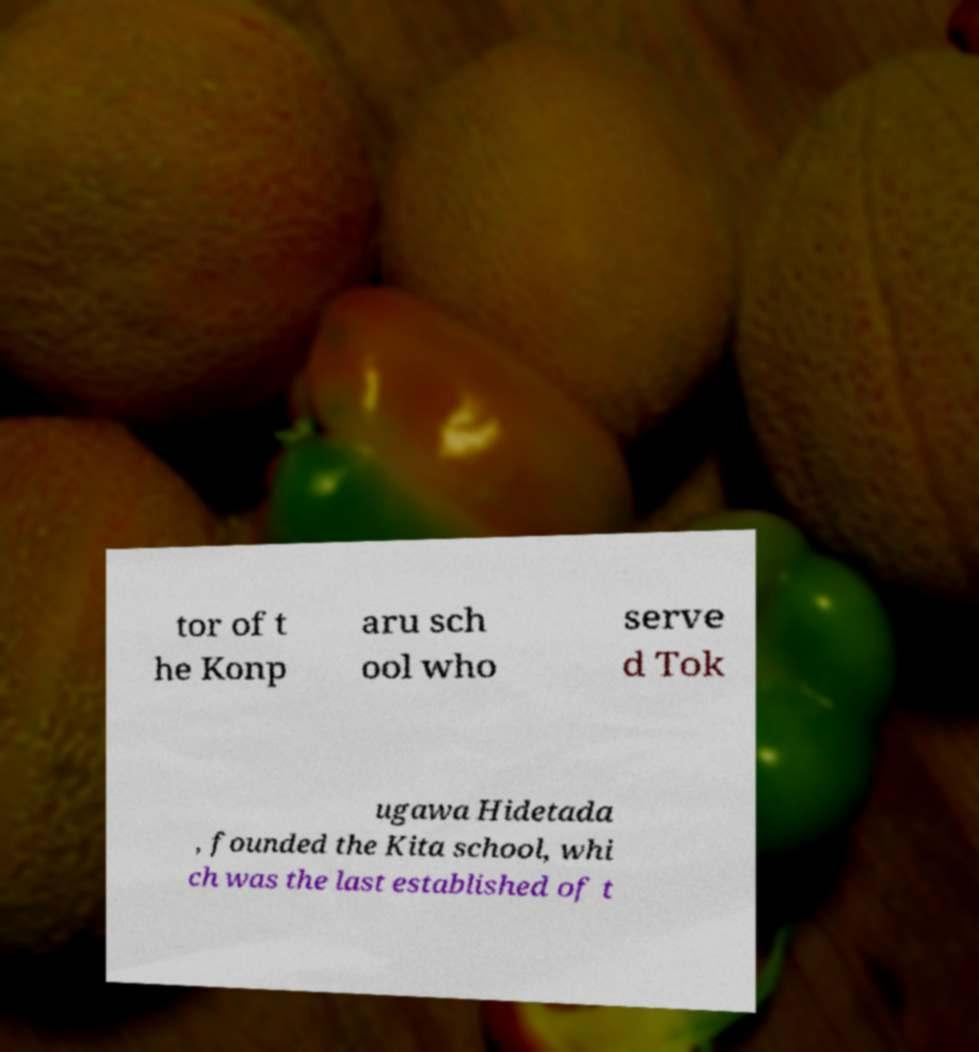What messages or text are displayed in this image? I need them in a readable, typed format. tor of t he Konp aru sch ool who serve d Tok ugawa Hidetada , founded the Kita school, whi ch was the last established of t 